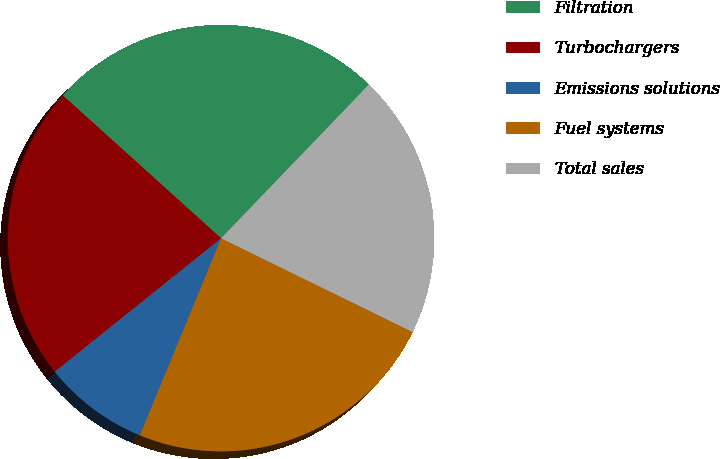Convert chart to OTSL. <chart><loc_0><loc_0><loc_500><loc_500><pie_chart><fcel>Filtration<fcel>Turbochargers<fcel>Emissions solutions<fcel>Fuel systems<fcel>Total sales<nl><fcel>25.5%<fcel>22.45%<fcel>8.02%<fcel>23.98%<fcel>20.05%<nl></chart> 